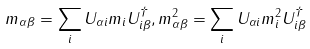Convert formula to latex. <formula><loc_0><loc_0><loc_500><loc_500>m _ { \alpha \beta } = \sum _ { i } U _ { \alpha i } m _ { i } U _ { i \beta } ^ { \dagger } , m _ { \alpha \beta } ^ { 2 } = \sum _ { i } U _ { \alpha i } m _ { i } ^ { 2 } U _ { i \beta } ^ { \dagger } \text { \quad }</formula> 